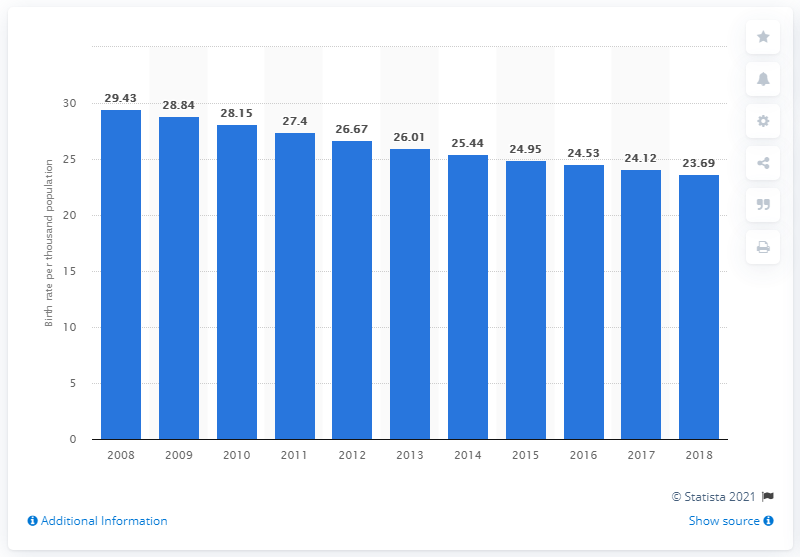Mention a couple of crucial points in this snapshot. In 2018, the crude birth rate in Syria was 23.69 per 1,000 population. 